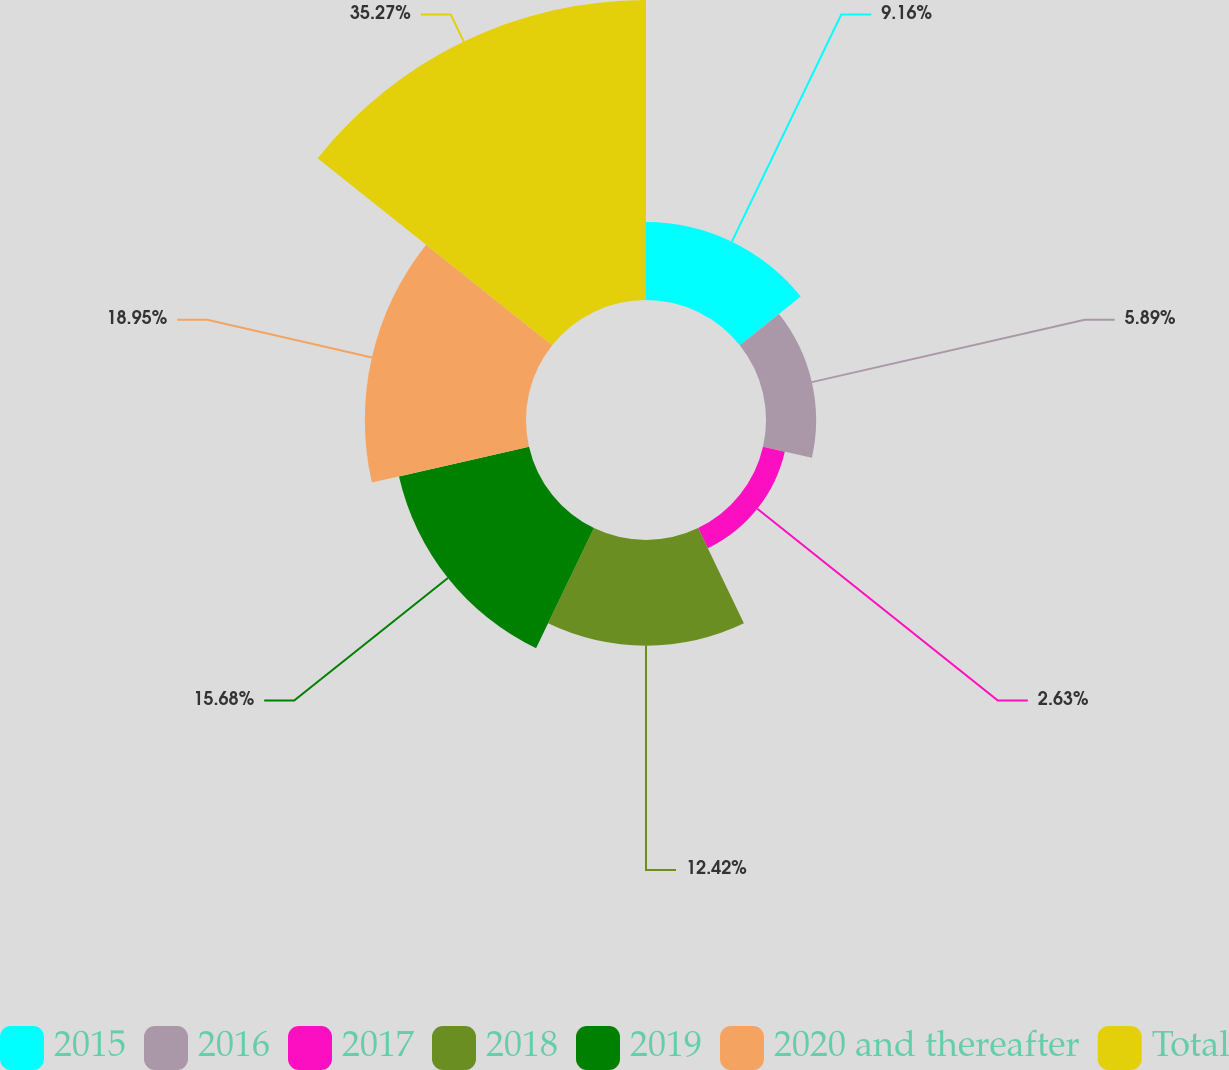Convert chart to OTSL. <chart><loc_0><loc_0><loc_500><loc_500><pie_chart><fcel>2015<fcel>2016<fcel>2017<fcel>2018<fcel>2019<fcel>2020 and thereafter<fcel>Total<nl><fcel>9.16%<fcel>5.89%<fcel>2.63%<fcel>12.42%<fcel>15.68%<fcel>18.95%<fcel>35.27%<nl></chart> 